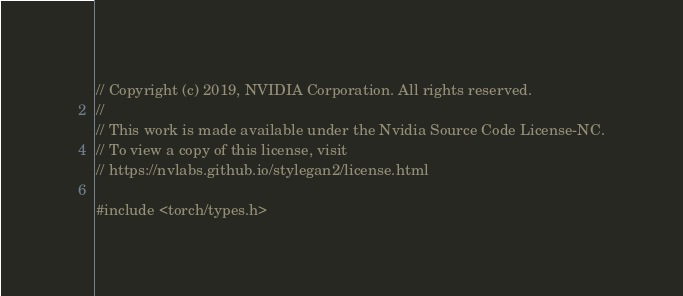<code> <loc_0><loc_0><loc_500><loc_500><_Cuda_>// Copyright (c) 2019, NVIDIA Corporation. All rights reserved.
//
// This work is made available under the Nvidia Source Code License-NC.
// To view a copy of this license, visit
// https://nvlabs.github.io/stylegan2/license.html

#include <torch/types.h>
</code> 